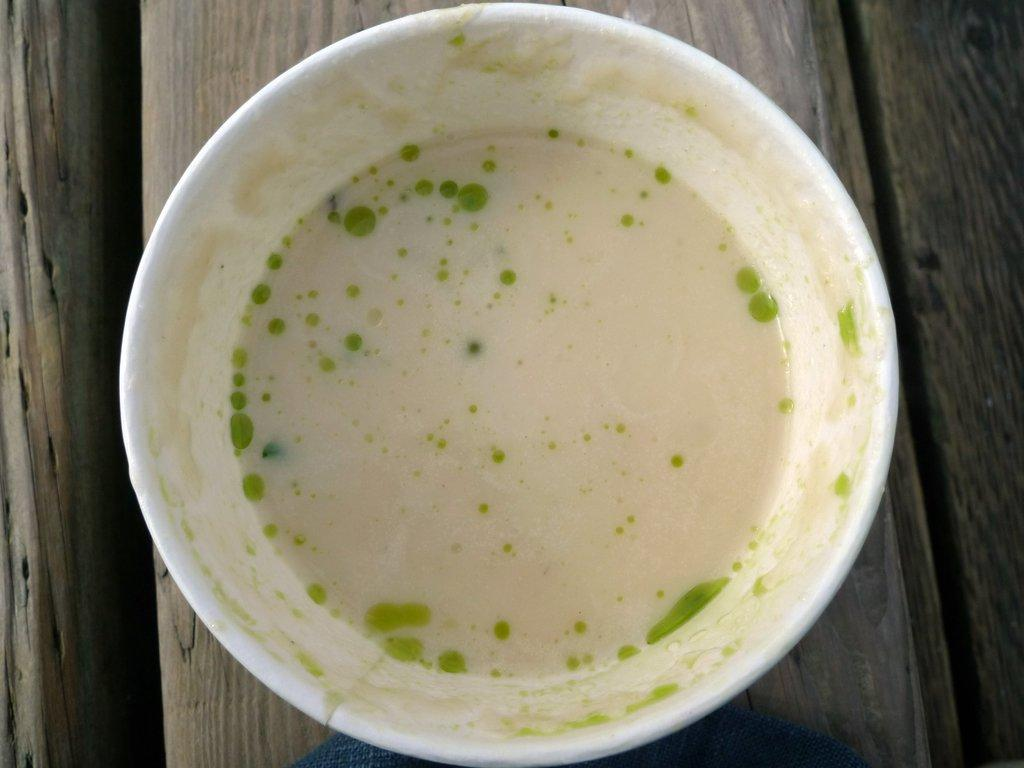What is in the bowl that is visible in the image? There is a bowl with liquid in the image. Where is the bowl located in the image? The bowl is placed on a table. How does the crow interact with the scale in the image? There is no crow or scale present in the image. 